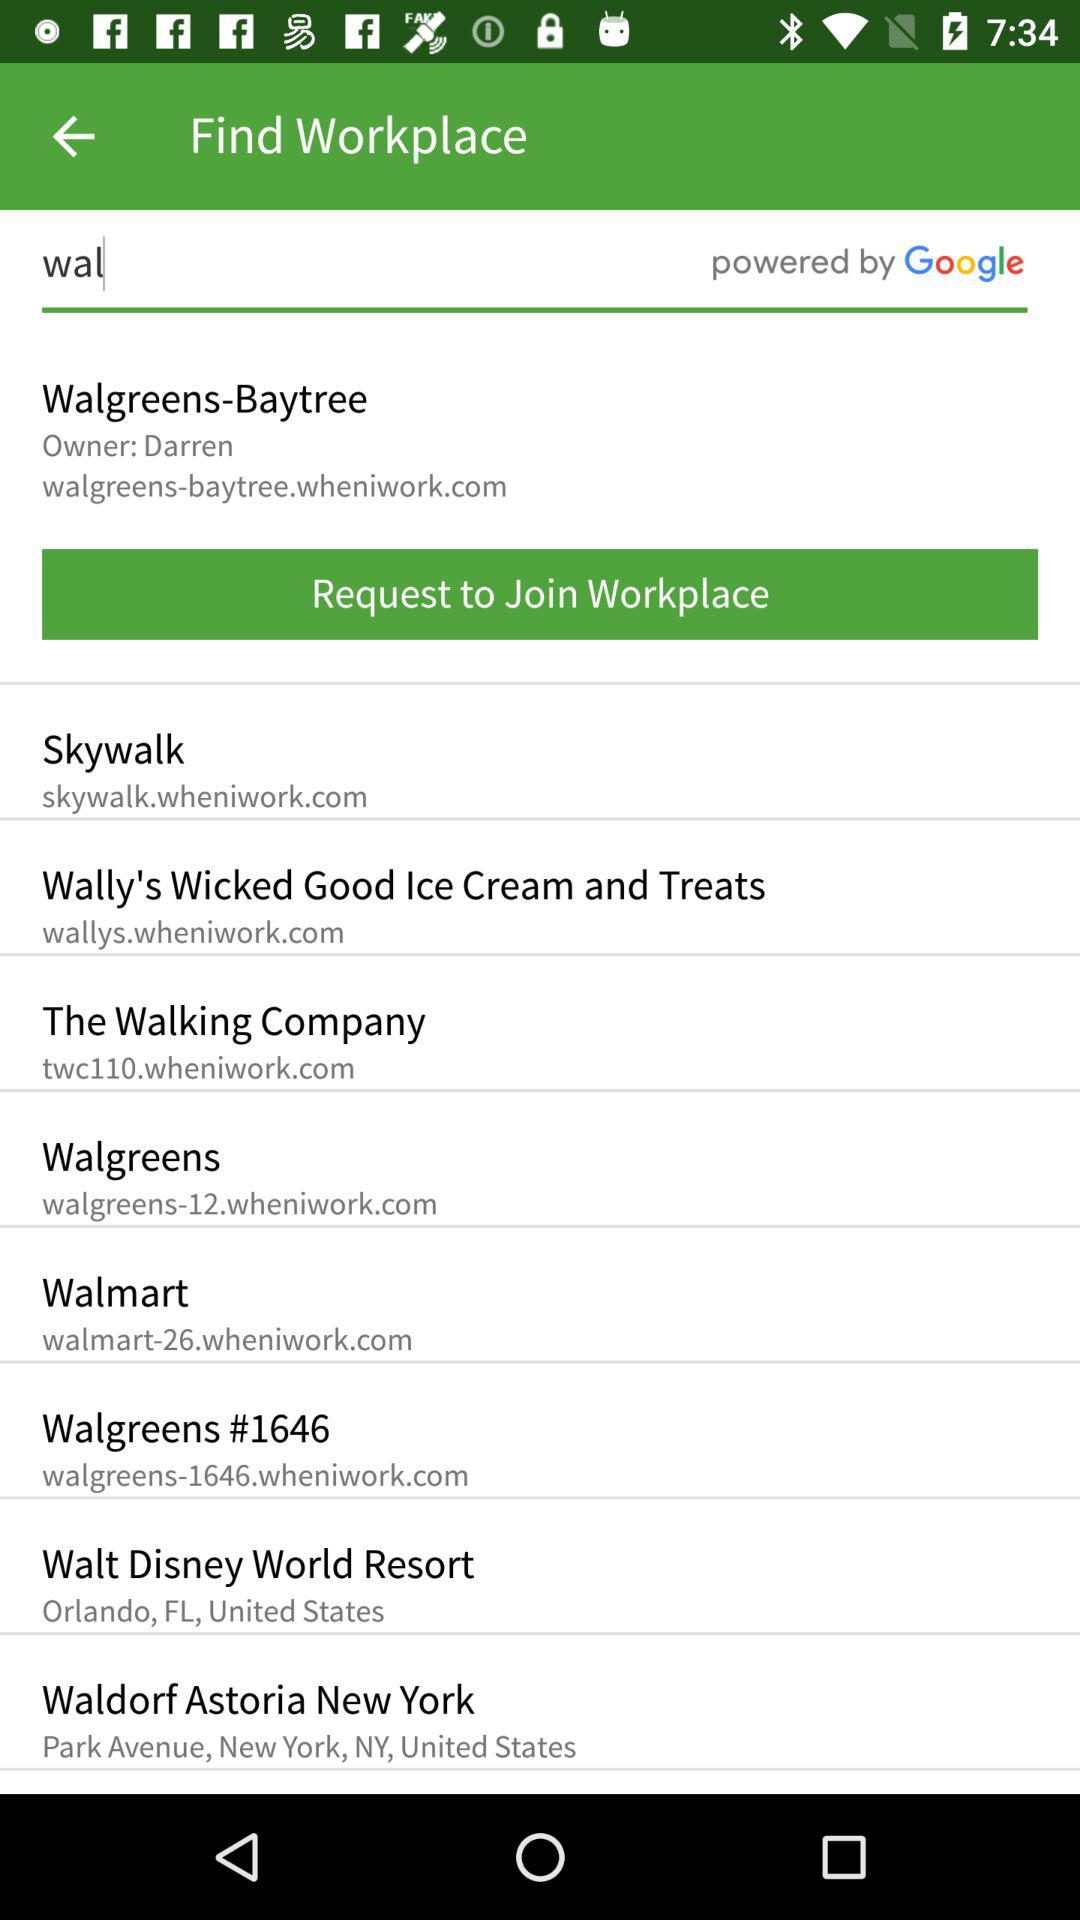Where is the Walt Disney World Resort located? It is located in Orlando, FL, United States. 